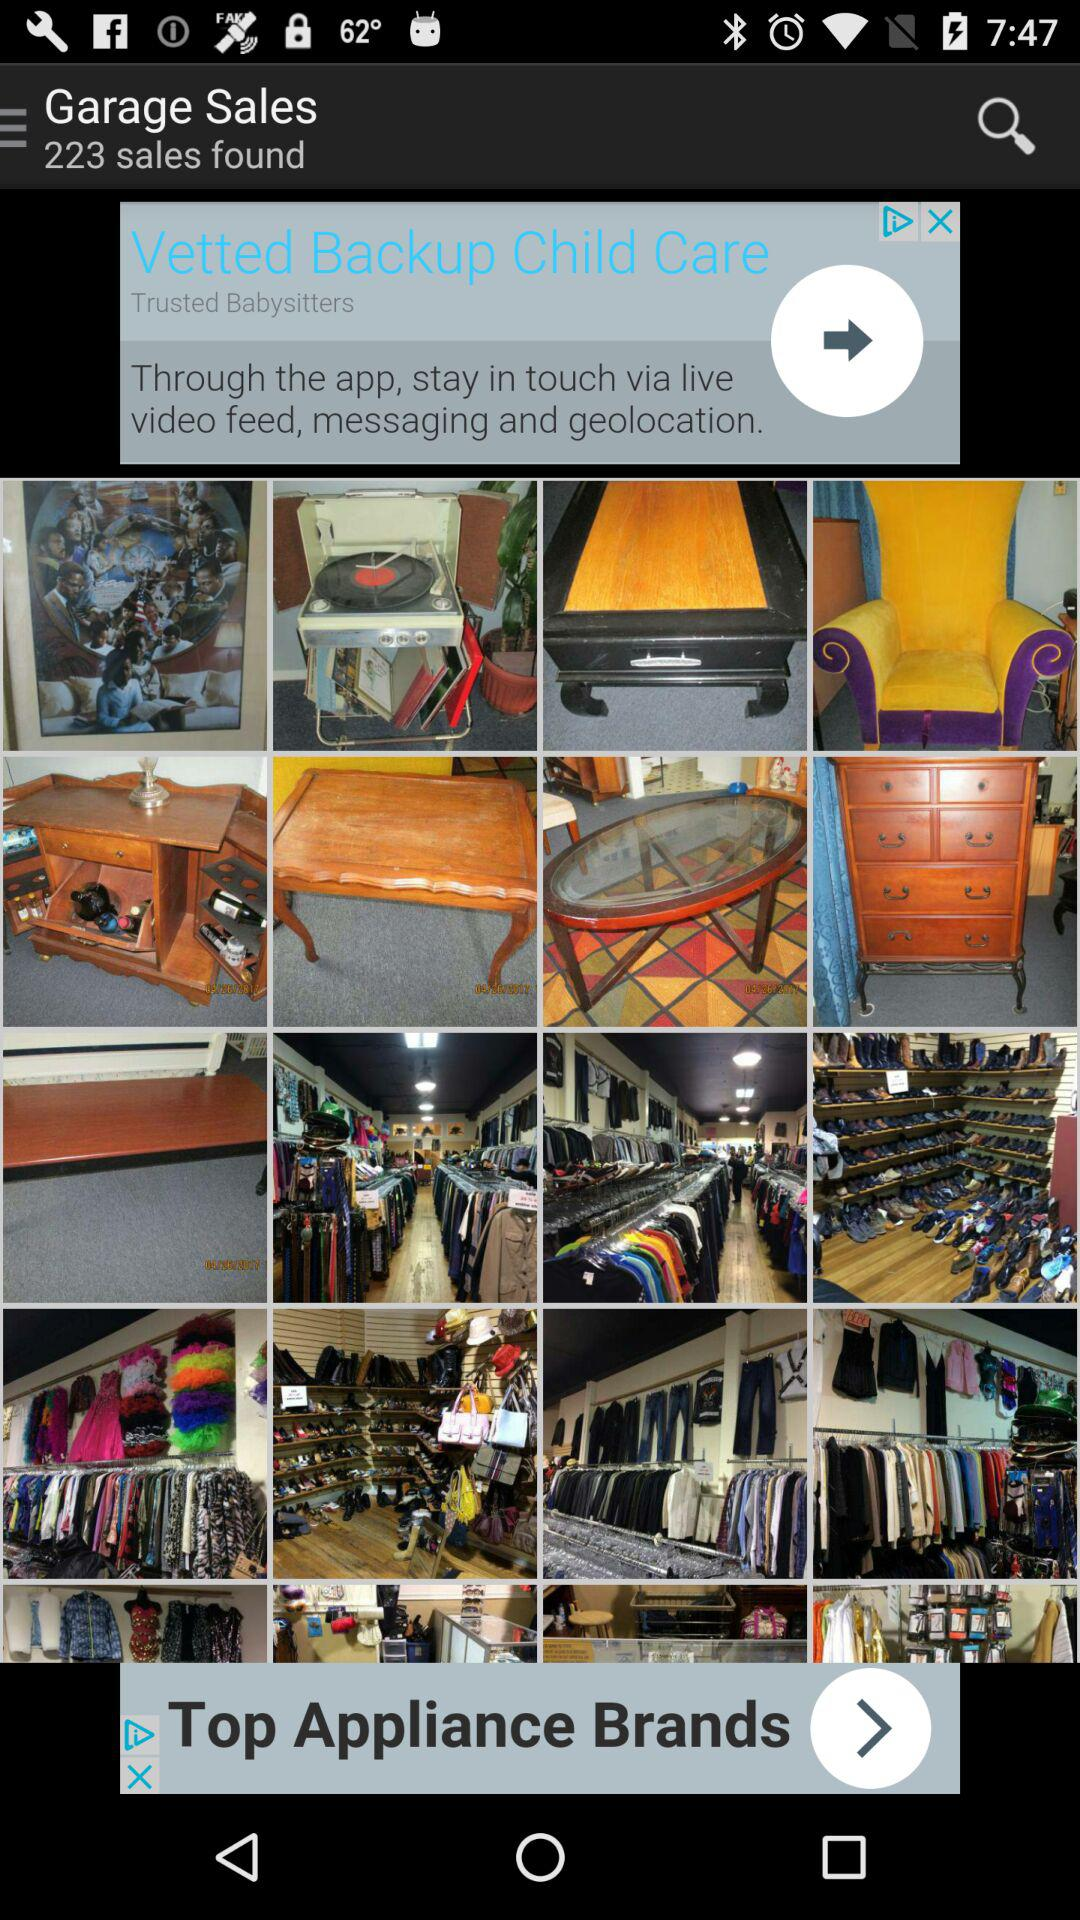How many sales are found? There are 223 sales found. 